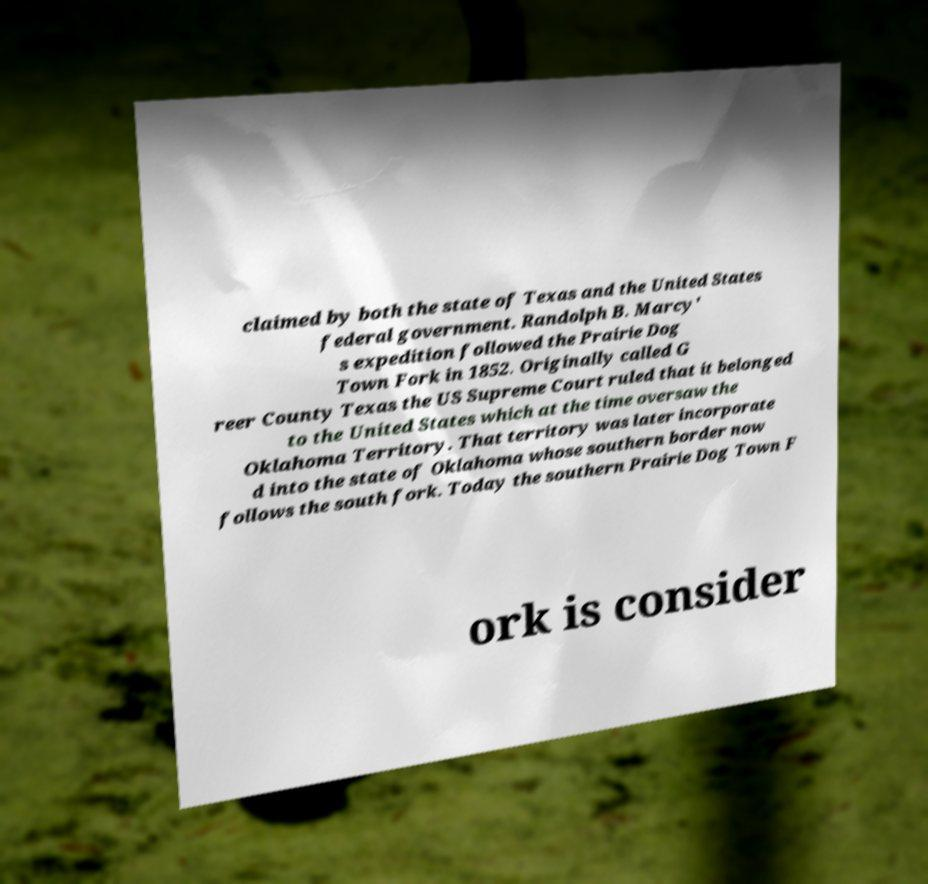Please identify and transcribe the text found in this image. claimed by both the state of Texas and the United States federal government. Randolph B. Marcy' s expedition followed the Prairie Dog Town Fork in 1852. Originally called G reer County Texas the US Supreme Court ruled that it belonged to the United States which at the time oversaw the Oklahoma Territory. That territory was later incorporate d into the state of Oklahoma whose southern border now follows the south fork. Today the southern Prairie Dog Town F ork is consider 